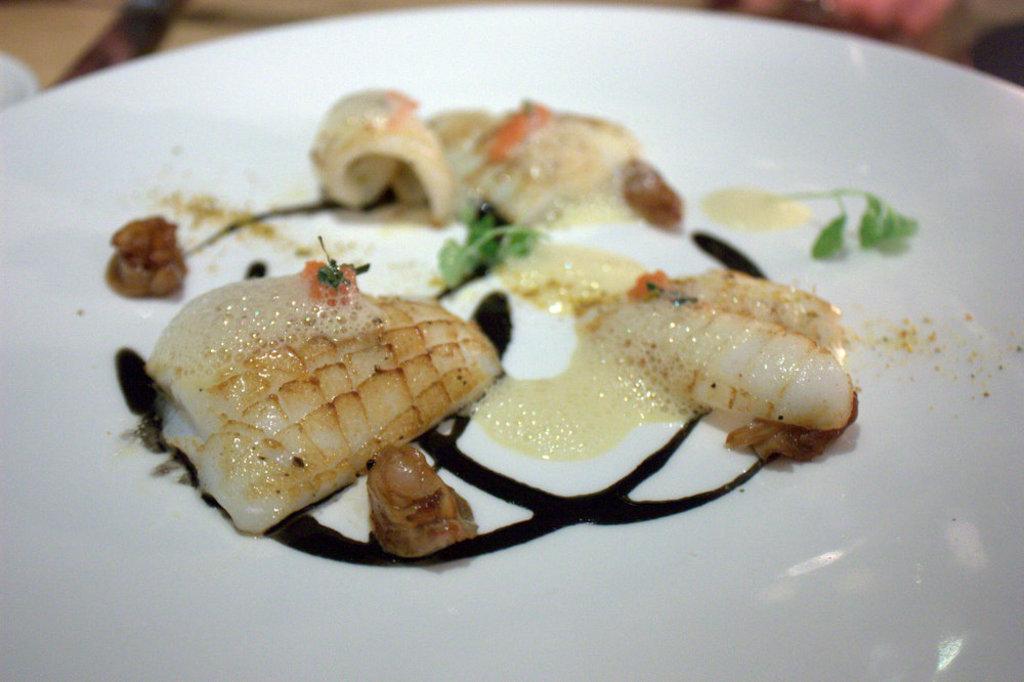How would you summarize this image in a sentence or two? In this image I can see a white color plate which consists of some food item in it. 